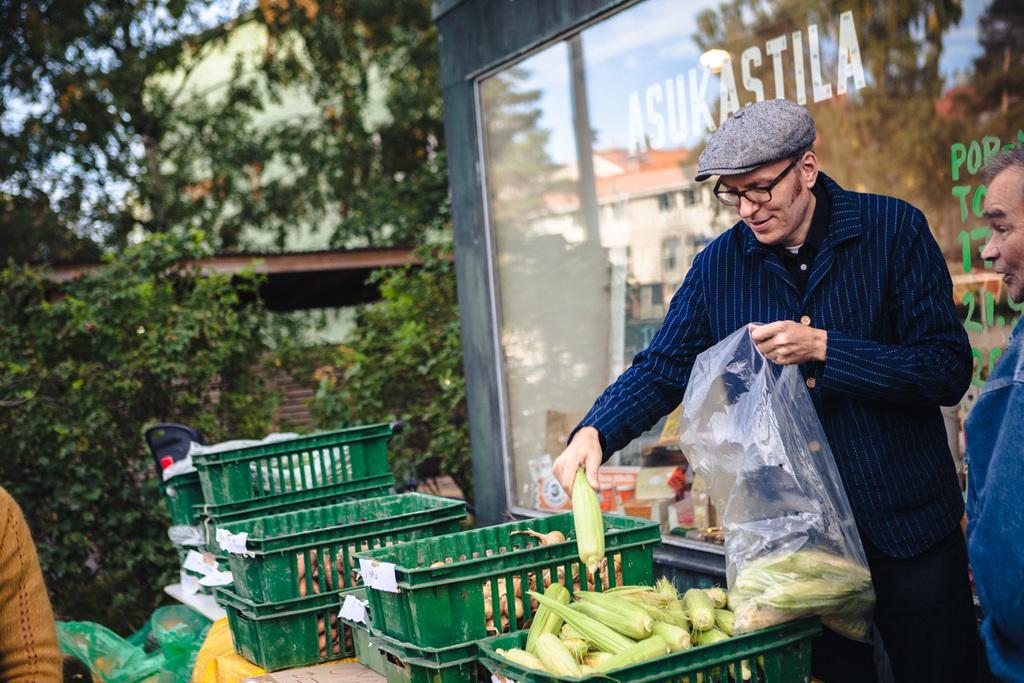In one or two sentences, can you explain what this image depicts? In this image we can see a man standing and holding a cover and a corn in his hands, next to him there is another person standing. At the bottom there is a table and we can see trays containing vegetables. On the left we can see a person's hand. In the background there are trees and buildings. There is sky. 